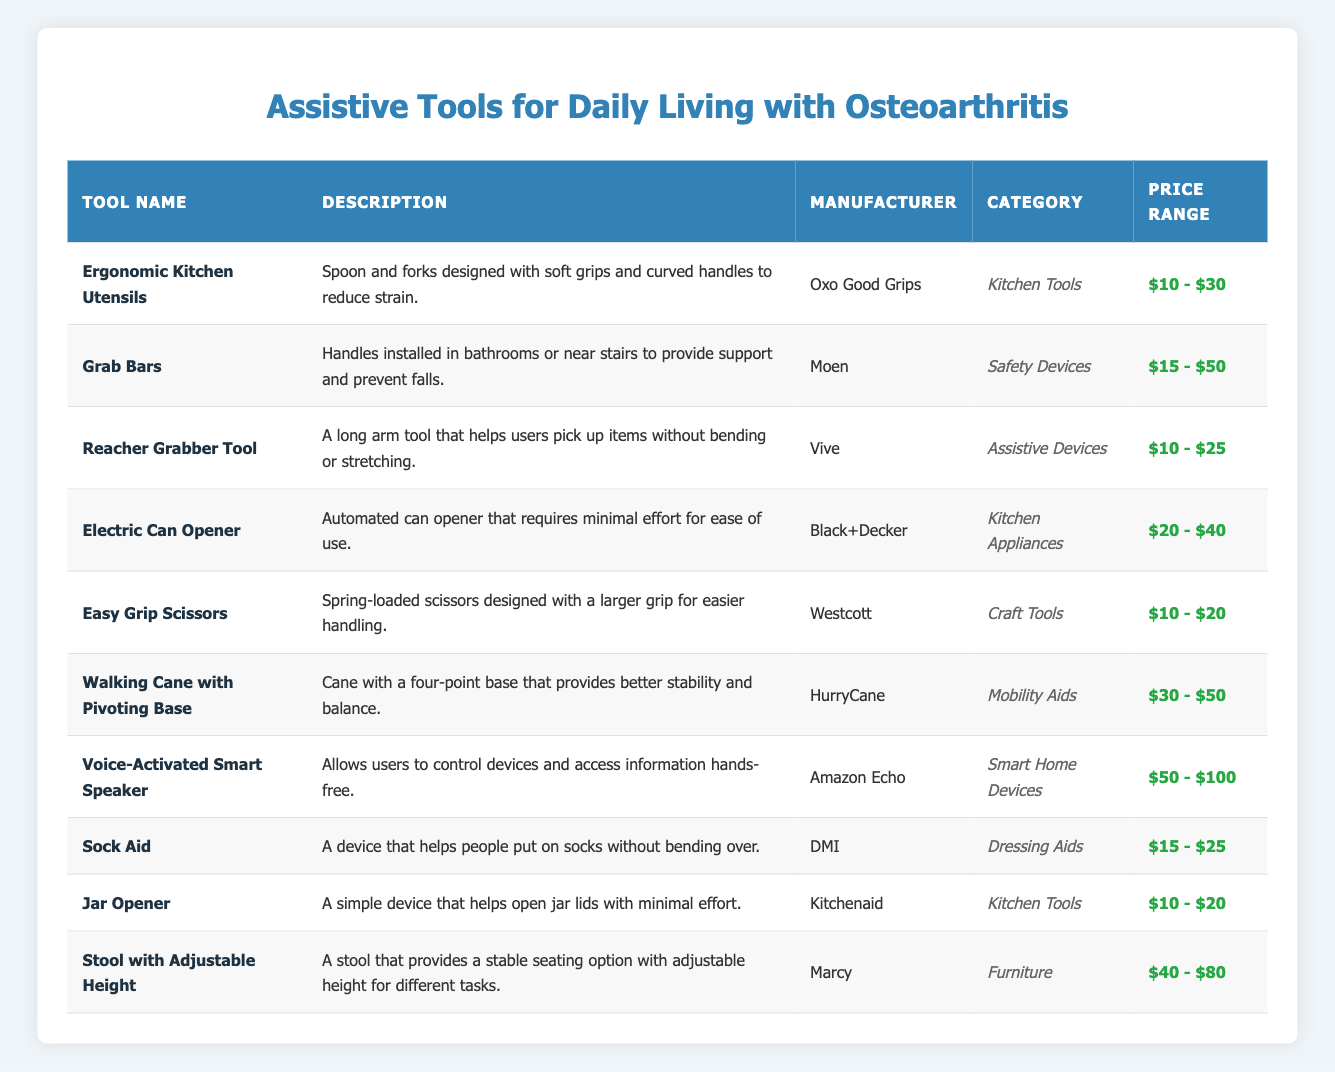What is the price range for the Electric Can Opener? The Electric Can Opener has a price range of $20 - $40 listed in the table. Therefore, I refer to the corresponding cell under the "Price Range" column for this tool.
Answer: $20 - $40 Which manufacturer produces the Easy Grip Scissors? The Easy Grip Scissors is manufactured by Westcott according to the table. This information is found in the "Manufacturer" column for that specific tool.
Answer: Westcott How many are the tools listed under Kitchen Tools category? There are three tools listed under the Kitchen Tools category: Ergonomic Kitchen Utensils, Jar Opener, and Electric Can Opener. To find this, I count the rows that specify "Kitchen Tools" in the "Category" column.
Answer: 3 Is the Voice-Activated Smart Speaker priced above $100? No, the Voice-Activated Smart Speaker is priced in the range of $50 - $100. Since the specified range does not exceed $100, I conclude that the statement is false by checking the "Price Range" column for this item.
Answer: No What is the average price range of the safety devices? There is one safety device listed: Grab Bars, with a price range of $15 - $50. Since there is only one device, the average is the same as the price range. Since there are no other devices in this category to consider, I identify and use this single price range.
Answer: $15 - $50 Which tool has a price range that overlaps with the price range of the Walking Cane with Pivoting Base? The Sock Aid with a price range of $15 - $25 overlaps, as it falls within the range of $15 - $50 for the Walking Cane with Pivoting Base. To find this, I check the "Price Range" column for both tools and identify the common values.
Answer: Sock Aid What features make the Ergonomic Kitchen Utensils helpful for users with osteoarthritis? The Ergonomic Kitchen Utensils feature soft grips and curved handles that specifically aim to reduce strain, which is crucial for users with osteoarthritis. The information is located in the "Description" column for this tool.
Answer: Soft grips and curved handles How many different categories of tools are represented in the table? There are six different categories represented: Kitchen Tools, Safety Devices, Assistive Devices, Kitchen Appliances, Craft Tools, Mobility Aids, Smart Home Devices, Dressing Aids, and Furniture. By checking the "Category" column, I identify and count each unique category mentioned in the table.
Answer: 8 What specific device helps with putting on socks without bending over? The device that helps with putting on socks without bending is the Sock Aid, as described in the "Description" column for that tool. The description explicitly states its purpose.
Answer: Sock Aid 